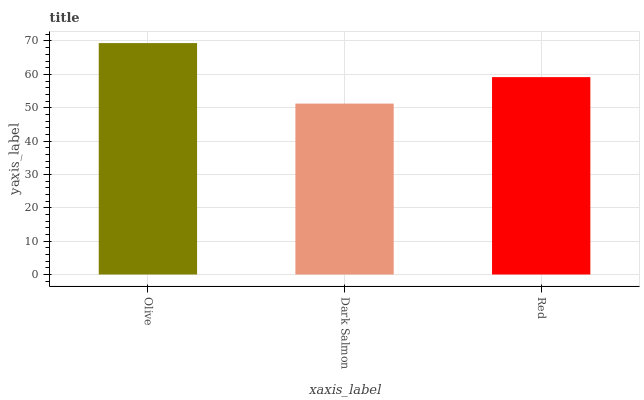Is Dark Salmon the minimum?
Answer yes or no. Yes. Is Olive the maximum?
Answer yes or no. Yes. Is Red the minimum?
Answer yes or no. No. Is Red the maximum?
Answer yes or no. No. Is Red greater than Dark Salmon?
Answer yes or no. Yes. Is Dark Salmon less than Red?
Answer yes or no. Yes. Is Dark Salmon greater than Red?
Answer yes or no. No. Is Red less than Dark Salmon?
Answer yes or no. No. Is Red the high median?
Answer yes or no. Yes. Is Red the low median?
Answer yes or no. Yes. Is Olive the high median?
Answer yes or no. No. Is Dark Salmon the low median?
Answer yes or no. No. 